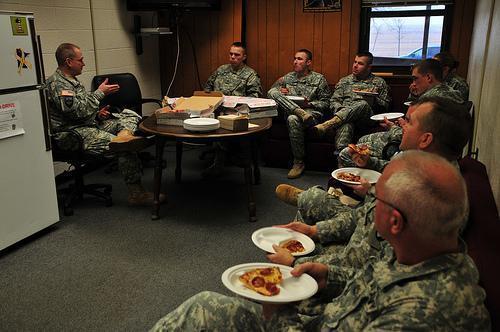How many soldiers are in the office?
Give a very brief answer. 9. 